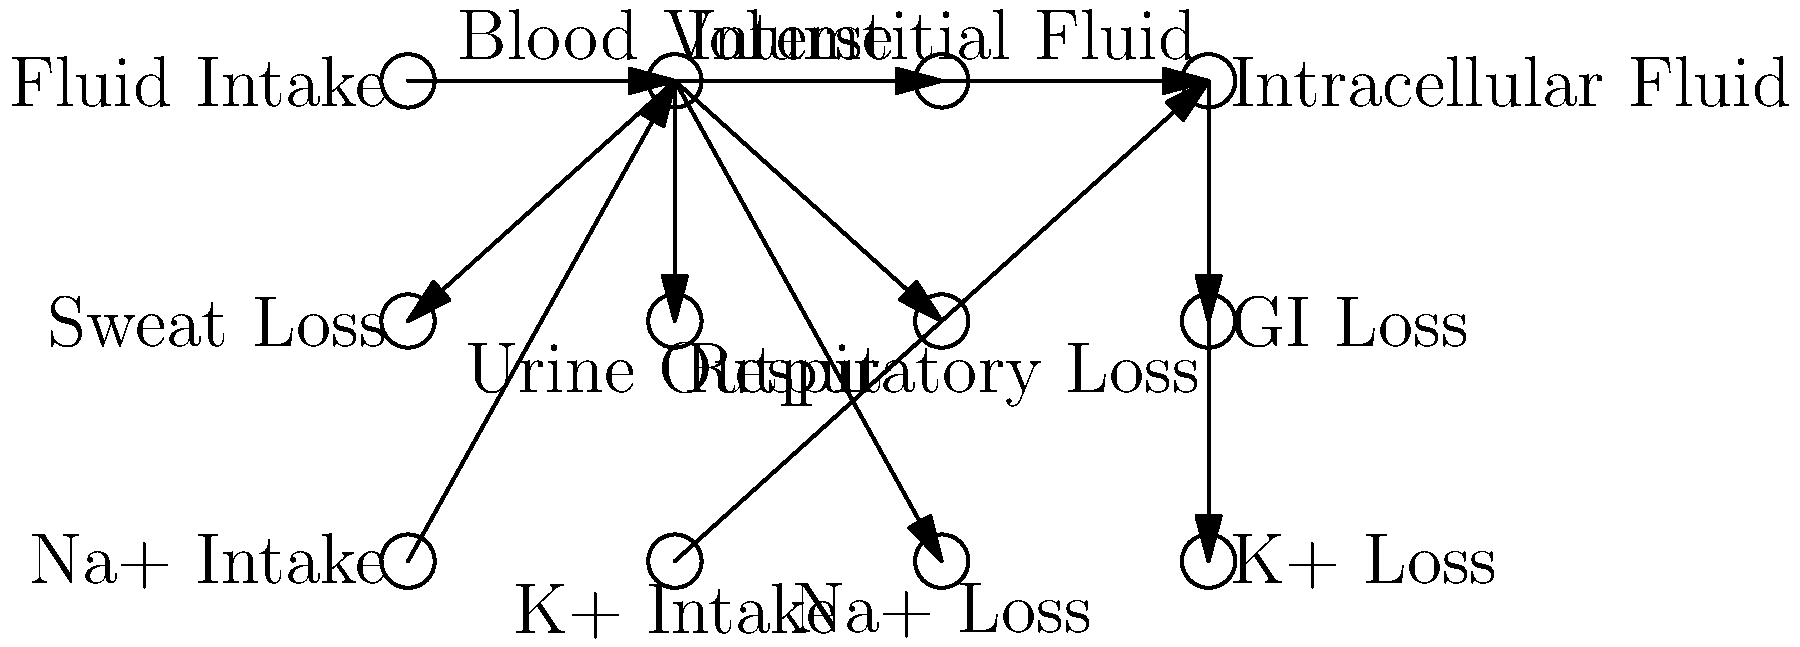Based on the flow diagram of fluid balance during prolonged exercise, which of the following statements is correct regarding the relationship between blood volume and other components?
A) Blood volume directly influences intracellular fluid without affecting interstitial fluid.
B) Blood volume is only affected by fluid intake and has no impact on fluid losses.
C) Blood volume has a direct impact on sweat loss, urine output, and respiratory loss.
D) Blood volume is solely regulated by sodium intake and loss. To answer this question correctly, we need to analyze the flow diagram and understand the relationships between blood volume and other components:

1. Blood volume (second node from left in the top row) is directly connected to several other components in the diagram.

2. We can see that fluid intake directly affects blood volume, as indicated by the arrow from "Fluid Intake" to "Blood Volume".

3. Blood volume is shown to have a direct impact on interstitial fluid, as there is an arrow from "Blood Volume" to "Interstitial Fluid".

4. There are arrows from "Blood Volume" directly to "Sweat Loss", "Urine Output", and "Respiratory Loss", indicating that blood volume directly influences these fluid loss mechanisms.

5. We can also see that sodium (Na+) intake and loss are connected to blood volume, but it's not the only factor affecting it.

6. Intracellular fluid is not directly connected to blood volume but is connected through interstitial fluid.

Analyzing the given options:
A) is incorrect because blood volume affects interstitial fluid before influencing intracellular fluid.
B) is incorrect because blood volume is shown to impact several fluid loss mechanisms.
C) is correct as it accurately describes the direct connections shown in the diagram.
D) is incorrect because while sodium does affect blood volume, it's not the sole regulator, and the diagram shows other factors influencing blood volume.

Therefore, the correct answer is C: Blood volume has a direct impact on sweat loss, urine output, and respiratory loss.
Answer: C) Blood volume has a direct impact on sweat loss, urine output, and respiratory loss. 